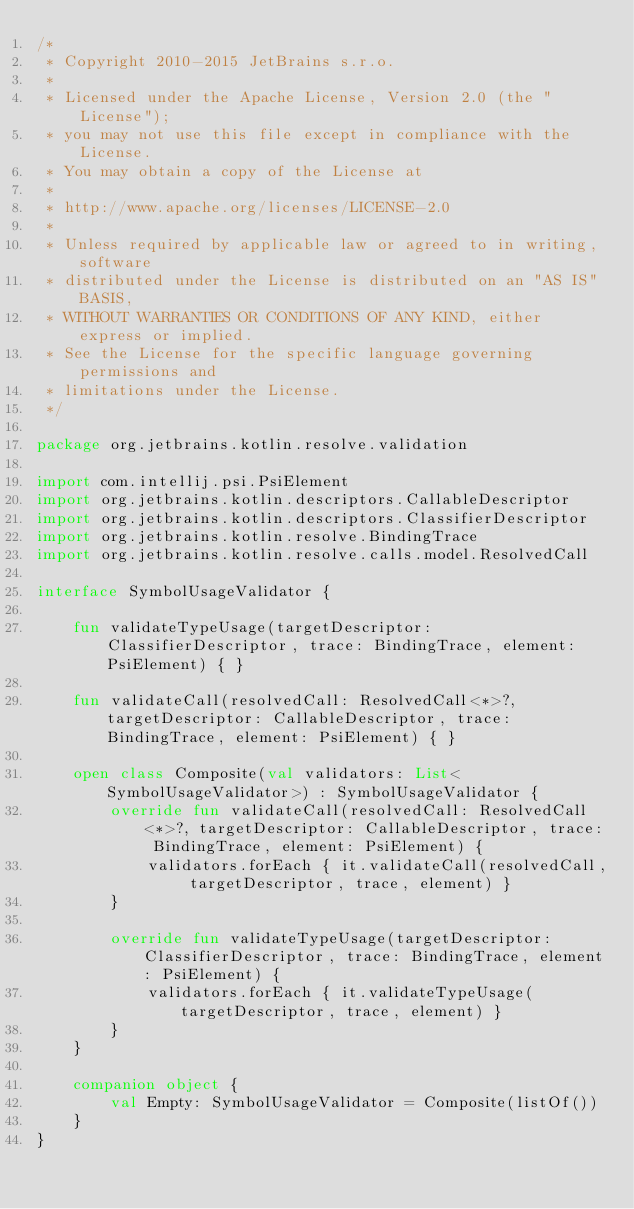Convert code to text. <code><loc_0><loc_0><loc_500><loc_500><_Kotlin_>/*
 * Copyright 2010-2015 JetBrains s.r.o.
 *
 * Licensed under the Apache License, Version 2.0 (the "License");
 * you may not use this file except in compliance with the License.
 * You may obtain a copy of the License at
 *
 * http://www.apache.org/licenses/LICENSE-2.0
 *
 * Unless required by applicable law or agreed to in writing, software
 * distributed under the License is distributed on an "AS IS" BASIS,
 * WITHOUT WARRANTIES OR CONDITIONS OF ANY KIND, either express or implied.
 * See the License for the specific language governing permissions and
 * limitations under the License.
 */

package org.jetbrains.kotlin.resolve.validation

import com.intellij.psi.PsiElement
import org.jetbrains.kotlin.descriptors.CallableDescriptor
import org.jetbrains.kotlin.descriptors.ClassifierDescriptor
import org.jetbrains.kotlin.resolve.BindingTrace
import org.jetbrains.kotlin.resolve.calls.model.ResolvedCall

interface SymbolUsageValidator {

    fun validateTypeUsage(targetDescriptor: ClassifierDescriptor, trace: BindingTrace, element: PsiElement) { }

    fun validateCall(resolvedCall: ResolvedCall<*>?, targetDescriptor: CallableDescriptor, trace: BindingTrace, element: PsiElement) { }

    open class Composite(val validators: List<SymbolUsageValidator>) : SymbolUsageValidator {
        override fun validateCall(resolvedCall: ResolvedCall<*>?, targetDescriptor: CallableDescriptor, trace: BindingTrace, element: PsiElement) {
            validators.forEach { it.validateCall(resolvedCall, targetDescriptor, trace, element) }
        }

        override fun validateTypeUsage(targetDescriptor: ClassifierDescriptor, trace: BindingTrace, element: PsiElement) {
            validators.forEach { it.validateTypeUsage(targetDescriptor, trace, element) }
        }
    }

    companion object {
        val Empty: SymbolUsageValidator = Composite(listOf())
    }
}</code> 